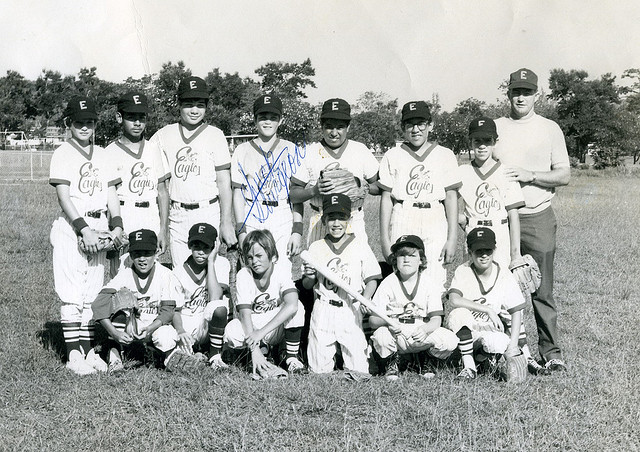<image>What Academy is the team from? I am not sure what academy the team is from. It could be Eagles or Rockford Peaches. What Academy is the team from? I don't know what Academy the team is from. It could be Eagles or unknown. 